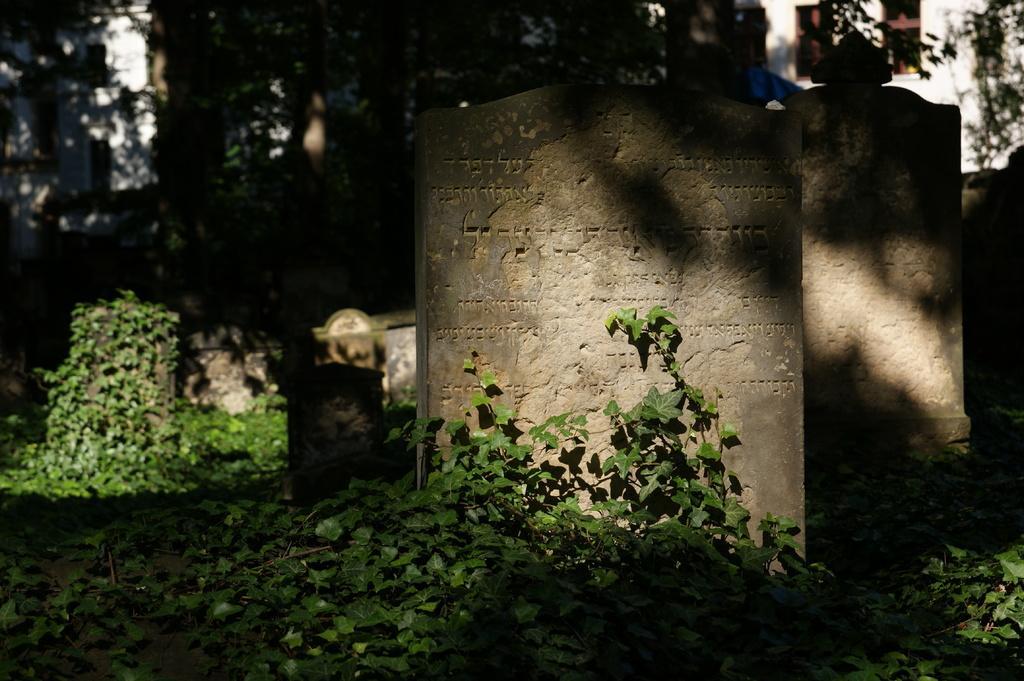Please provide a concise description of this image. In this image we can see few buildings and they are having few windows. There are many plants in the image. There is a graveyard in the image. We can see some text on the memorial stones. 